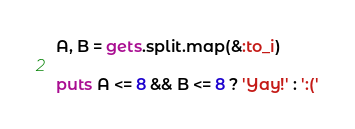Convert code to text. <code><loc_0><loc_0><loc_500><loc_500><_Ruby_>A, B = gets.split.map(&:to_i)

puts A <= 8 && B <= 8 ? 'Yay!' : ':('
</code> 